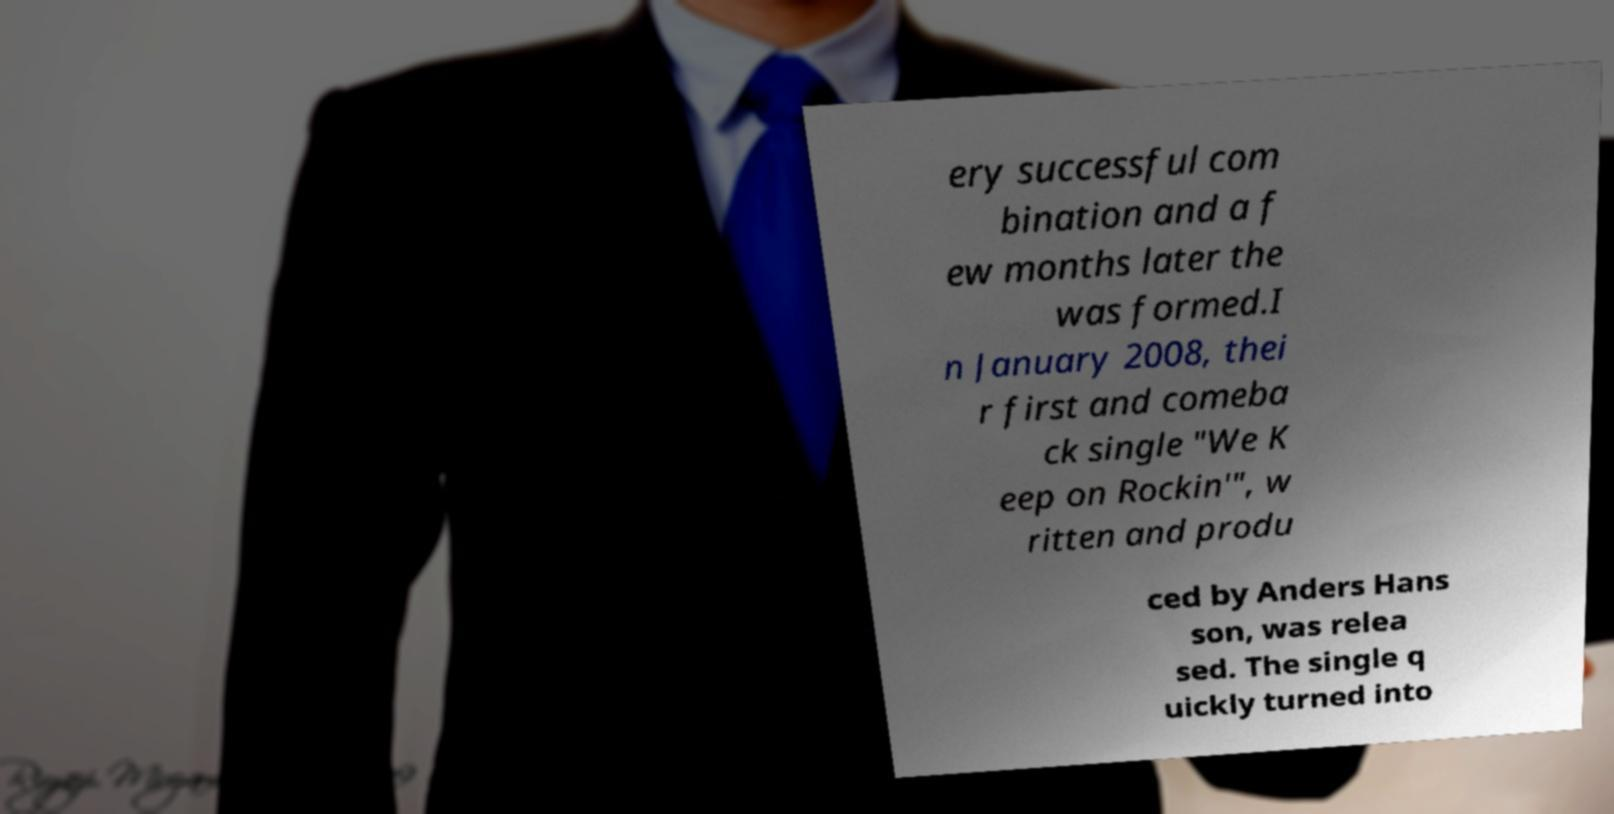I need the written content from this picture converted into text. Can you do that? ery successful com bination and a f ew months later the was formed.I n January 2008, thei r first and comeba ck single "We K eep on Rockin'", w ritten and produ ced by Anders Hans son, was relea sed. The single q uickly turned into 